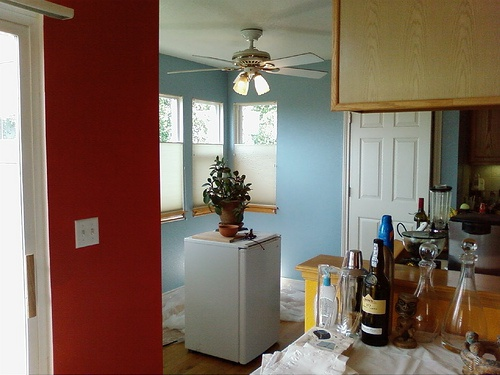Describe the objects in this image and their specific colors. I can see refrigerator in gray and darkgray tones, bottle in gray, black, darkgray, and tan tones, potted plant in gray, black, and maroon tones, bottle in gray, black, and darkgray tones, and bottle in gray, darkgray, and lightgray tones in this image. 